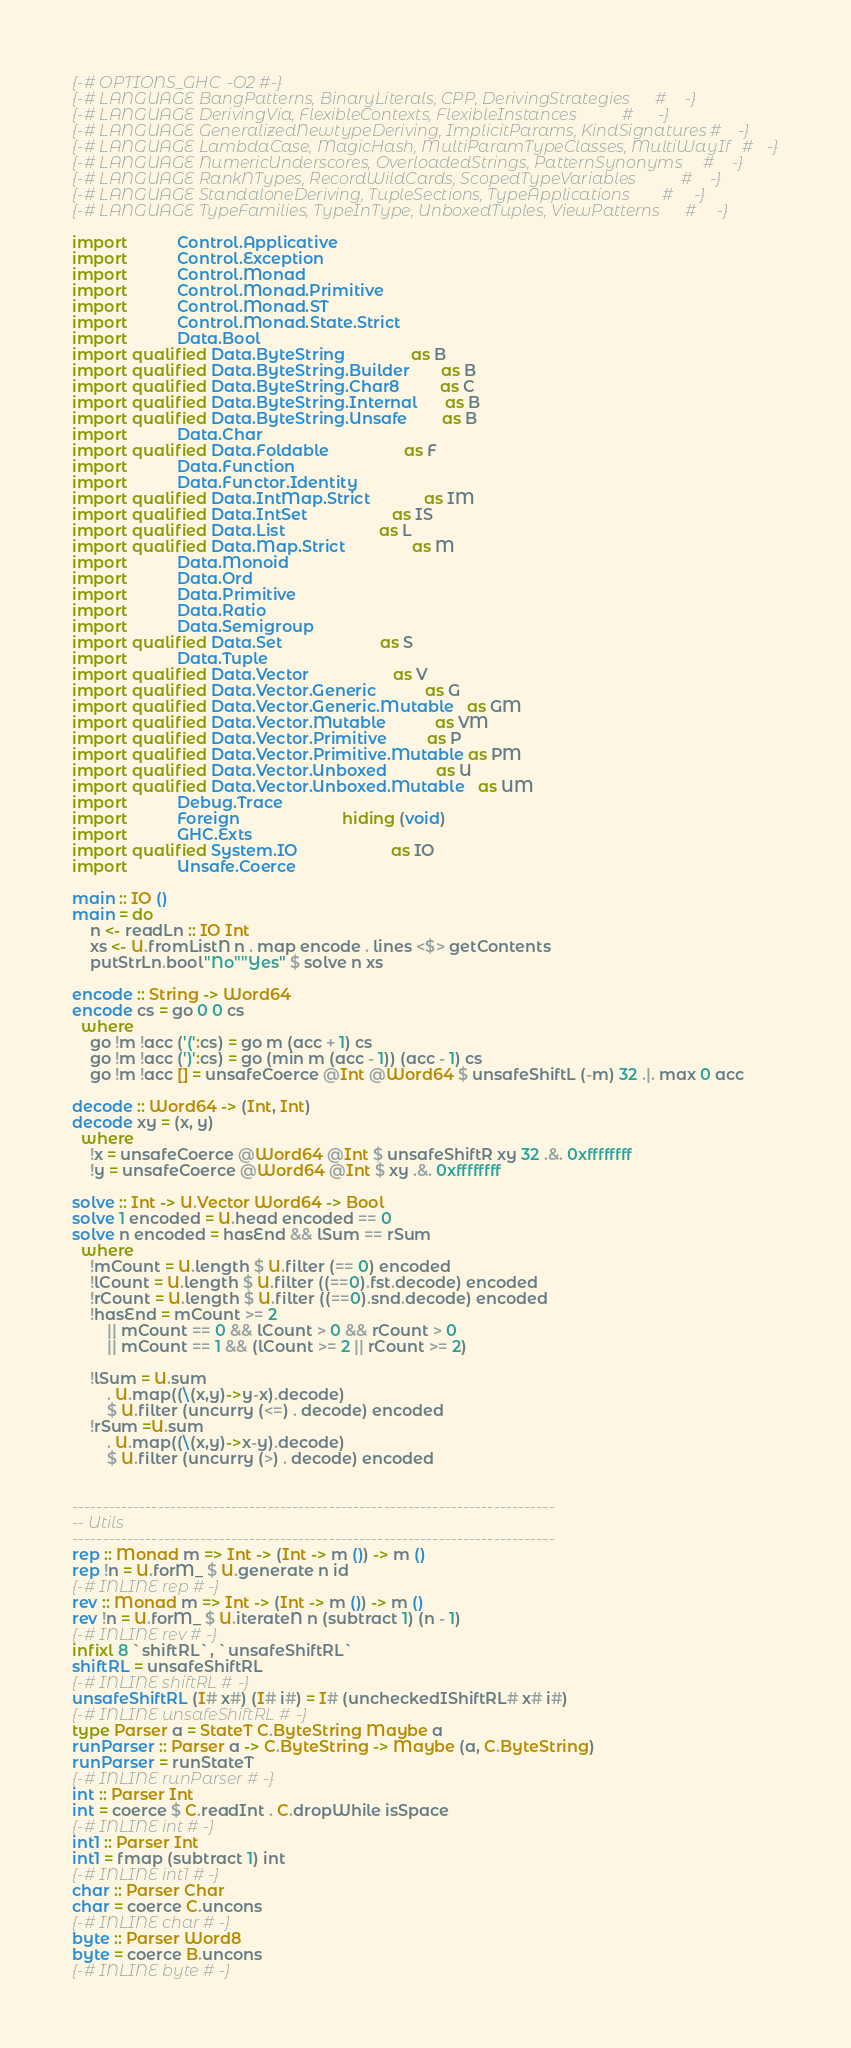Convert code to text. <code><loc_0><loc_0><loc_500><loc_500><_Haskell_>{-# OPTIONS_GHC -O2 #-}
{-# LANGUAGE BangPatterns, BinaryLiterals, CPP, DerivingStrategies      #-}
{-# LANGUAGE DerivingVia, FlexibleContexts, FlexibleInstances           #-}
{-# LANGUAGE GeneralizedNewtypeDeriving, ImplicitParams, KindSignatures #-}
{-# LANGUAGE LambdaCase, MagicHash, MultiParamTypeClasses, MultiWayIf   #-}
{-# LANGUAGE NumericUnderscores, OverloadedStrings, PatternSynonyms     #-}
{-# LANGUAGE RankNTypes, RecordWildCards, ScopedTypeVariables           #-}
{-# LANGUAGE StandaloneDeriving, TupleSections, TypeApplications        #-}
{-# LANGUAGE TypeFamilies, TypeInType, UnboxedTuples, ViewPatterns      #-}

import           Control.Applicative
import           Control.Exception
import           Control.Monad
import           Control.Monad.Primitive
import           Control.Monad.ST
import           Control.Monad.State.Strict
import           Data.Bool
import qualified Data.ByteString               as B
import qualified Data.ByteString.Builder       as B
import qualified Data.ByteString.Char8         as C
import qualified Data.ByteString.Internal      as B
import qualified Data.ByteString.Unsafe        as B
import           Data.Char
import qualified Data.Foldable                 as F
import           Data.Function
import           Data.Functor.Identity
import qualified Data.IntMap.Strict            as IM
import qualified Data.IntSet                   as IS
import qualified Data.List                     as L
import qualified Data.Map.Strict               as M
import           Data.Monoid
import           Data.Ord
import           Data.Primitive
import           Data.Ratio
import           Data.Semigroup
import qualified Data.Set                      as S
import           Data.Tuple
import qualified Data.Vector                   as V
import qualified Data.Vector.Generic           as G
import qualified Data.Vector.Generic.Mutable   as GM
import qualified Data.Vector.Mutable           as VM
import qualified Data.Vector.Primitive         as P
import qualified Data.Vector.Primitive.Mutable as PM
import qualified Data.Vector.Unboxed           as U
import qualified Data.Vector.Unboxed.Mutable   as UM
import           Debug.Trace
import           Foreign                       hiding (void)
import           GHC.Exts
import qualified System.IO                     as IO
import           Unsafe.Coerce

main :: IO ()
main = do
    n <- readLn :: IO Int
    xs <- U.fromListN n . map encode . lines <$> getContents
    putStrLn.bool"No""Yes" $ solve n xs

encode :: String -> Word64
encode cs = go 0 0 cs
  where
    go !m !acc ('(':cs) = go m (acc + 1) cs
    go !m !acc (')':cs) = go (min m (acc - 1)) (acc - 1) cs
    go !m !acc [] = unsafeCoerce @Int @Word64 $ unsafeShiftL (-m) 32 .|. max 0 acc

decode :: Word64 -> (Int, Int)
decode xy = (x, y)
  where
    !x = unsafeCoerce @Word64 @Int $ unsafeShiftR xy 32 .&. 0xffffffff
    !y = unsafeCoerce @Word64 @Int $ xy .&. 0xffffffff

solve :: Int -> U.Vector Word64 -> Bool
solve 1 encoded = U.head encoded == 0
solve n encoded = hasEnd && lSum == rSum
  where
    !mCount = U.length $ U.filter (== 0) encoded
    !lCount = U.length $ U.filter ((==0).fst.decode) encoded
    !rCount = U.length $ U.filter ((==0).snd.decode) encoded
    !hasEnd = mCount >= 2
        || mCount == 0 && lCount > 0 && rCount > 0
        || mCount == 1 && (lCount >= 2 || rCount >= 2)

    !lSum = U.sum
        . U.map((\(x,y)->y-x).decode)
        $ U.filter (uncurry (<=) . decode) encoded
    !rSum =U.sum
        . U.map((\(x,y)->x-y).decode)
        $ U.filter (uncurry (>) . decode) encoded


-------------------------------------------------------------------------------
-- Utils
-------------------------------------------------------------------------------
rep :: Monad m => Int -> (Int -> m ()) -> m ()
rep !n = U.forM_ $ U.generate n id
{-# INLINE rep #-}
rev :: Monad m => Int -> (Int -> m ()) -> m ()
rev !n = U.forM_ $ U.iterateN n (subtract 1) (n - 1)
{-# INLINE rev #-}
infixl 8 `shiftRL`, `unsafeShiftRL`
shiftRL = unsafeShiftRL
{-# INLINE shiftRL #-}
unsafeShiftRL (I# x#) (I# i#) = I# (uncheckedIShiftRL# x# i#)
{-# INLINE unsafeShiftRL #-}
type Parser a = StateT C.ByteString Maybe a
runParser :: Parser a -> C.ByteString -> Maybe (a, C.ByteString)
runParser = runStateT
{-# INLINE runParser #-}
int :: Parser Int
int = coerce $ C.readInt . C.dropWhile isSpace
{-# INLINE int #-}
int1 :: Parser Int
int1 = fmap (subtract 1) int
{-# INLINE int1 #-}
char :: Parser Char
char = coerce C.uncons
{-# INLINE char #-}
byte :: Parser Word8
byte = coerce B.uncons
{-# INLINE byte #-}

</code> 